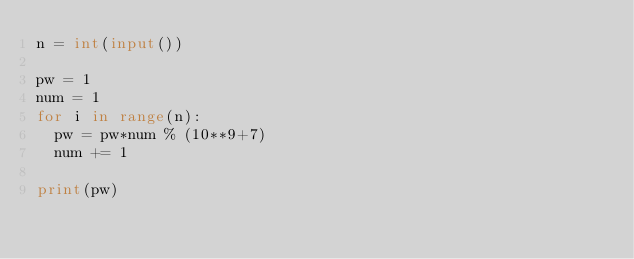Convert code to text. <code><loc_0><loc_0><loc_500><loc_500><_Python_>n = int(input())

pw = 1
num = 1
for i in range(n):
  pw = pw*num % (10**9+7)
  num += 1
  
print(pw)</code> 